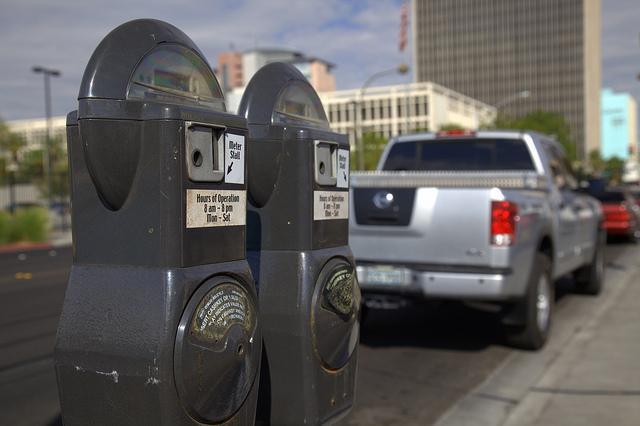How many parking meters are visible?
Give a very brief answer. 2. How many people are wearing hats?
Give a very brief answer. 0. 